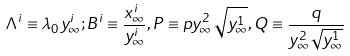Convert formula to latex. <formula><loc_0><loc_0><loc_500><loc_500>\Lambda ^ { i } \equiv \lambda _ { 0 } y _ { \infty } ^ { i } ; B ^ { i } \equiv \frac { x _ { \infty } ^ { i } } { y _ { \infty } ^ { i } } , P \equiv p y _ { \infty } ^ { 2 } \sqrt { y _ { \infty } ^ { 1 } } , Q \equiv \frac { q } { y _ { \infty } ^ { 2 } \sqrt { y _ { \infty } ^ { 1 } } }</formula> 